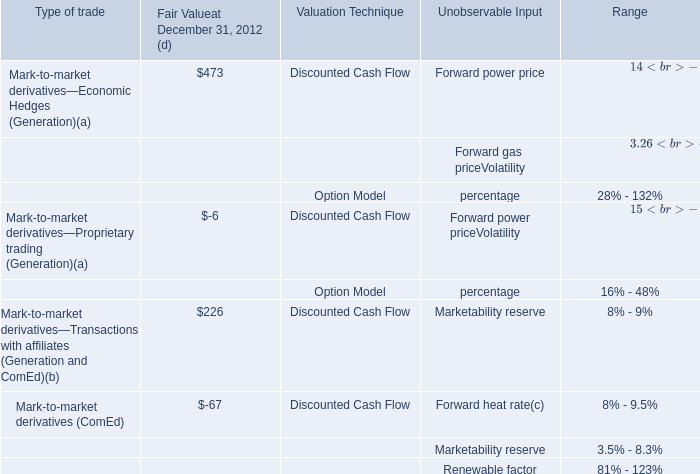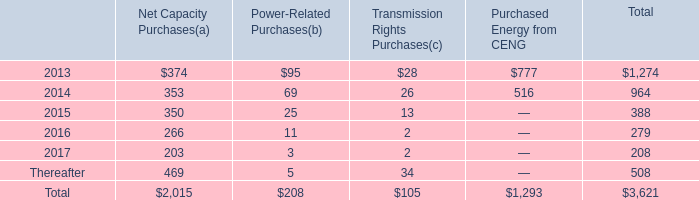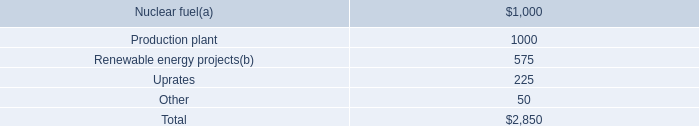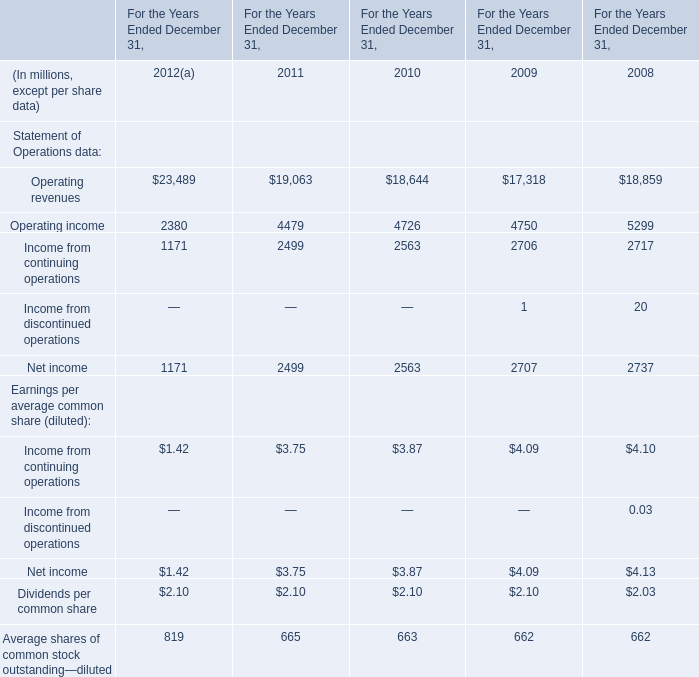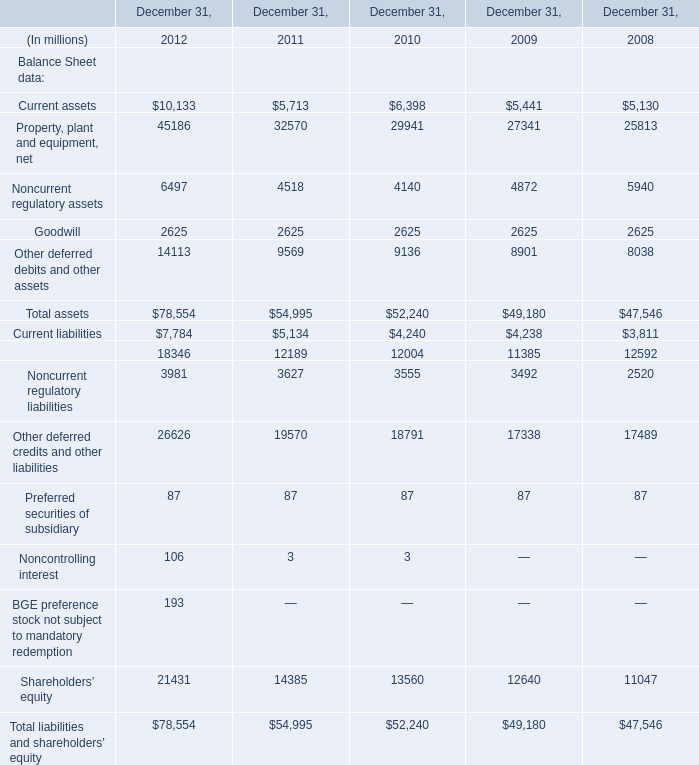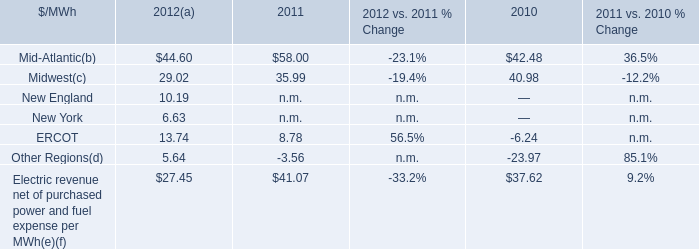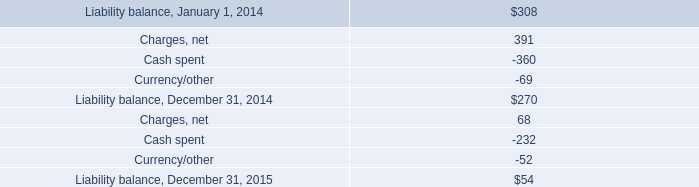what was the difference in cash payments related to exit costs at pmi from 2013 to 2014 in millions? 
Computations: (360 - 21)
Answer: 339.0. 